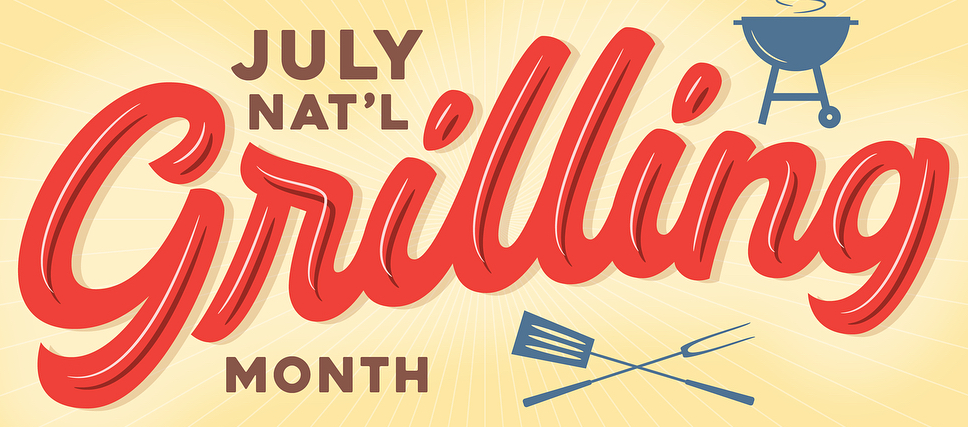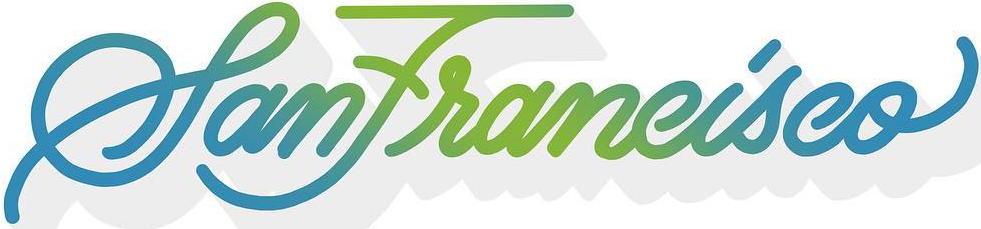What text is displayed in these images sequentially, separated by a semicolon? Grilling; SanFrancisco 